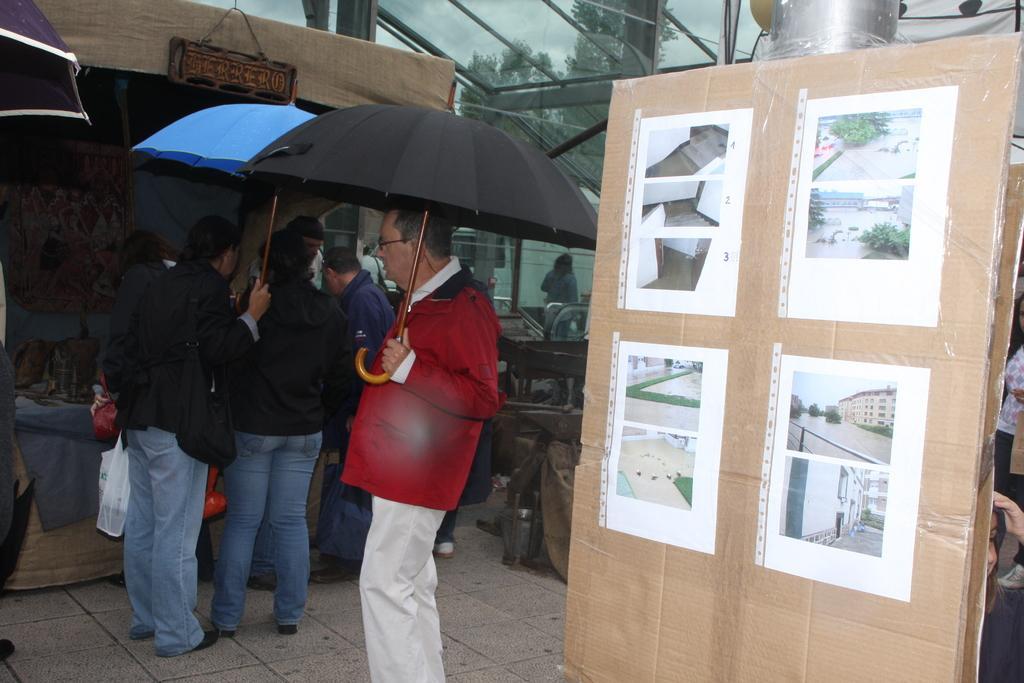Describe this image in one or two sentences. In this image we can see a man is standing. He is wearing red color jacket, white pant and holding black umbrella. Right side of the image, we can see your papers are pasted on cardboard. Background of the image, one stall is there and people are standing. Two persons are wearing black color top with jeans and one person is holding blue color umbrella. At the top of the image, we can see glass shelter. Behind the shelter, tree and clouds are there. 